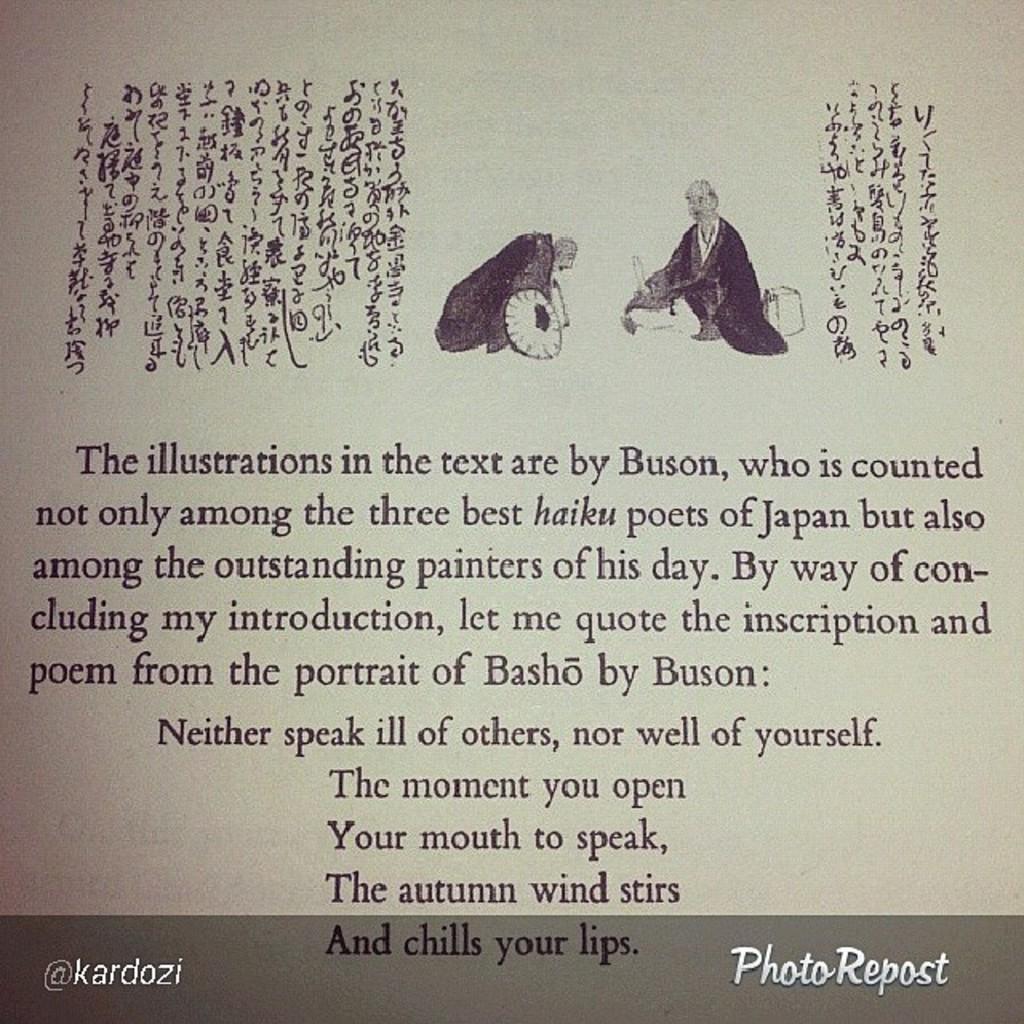What is the last line of the poem?
Offer a very short reply. And chills your lips. 